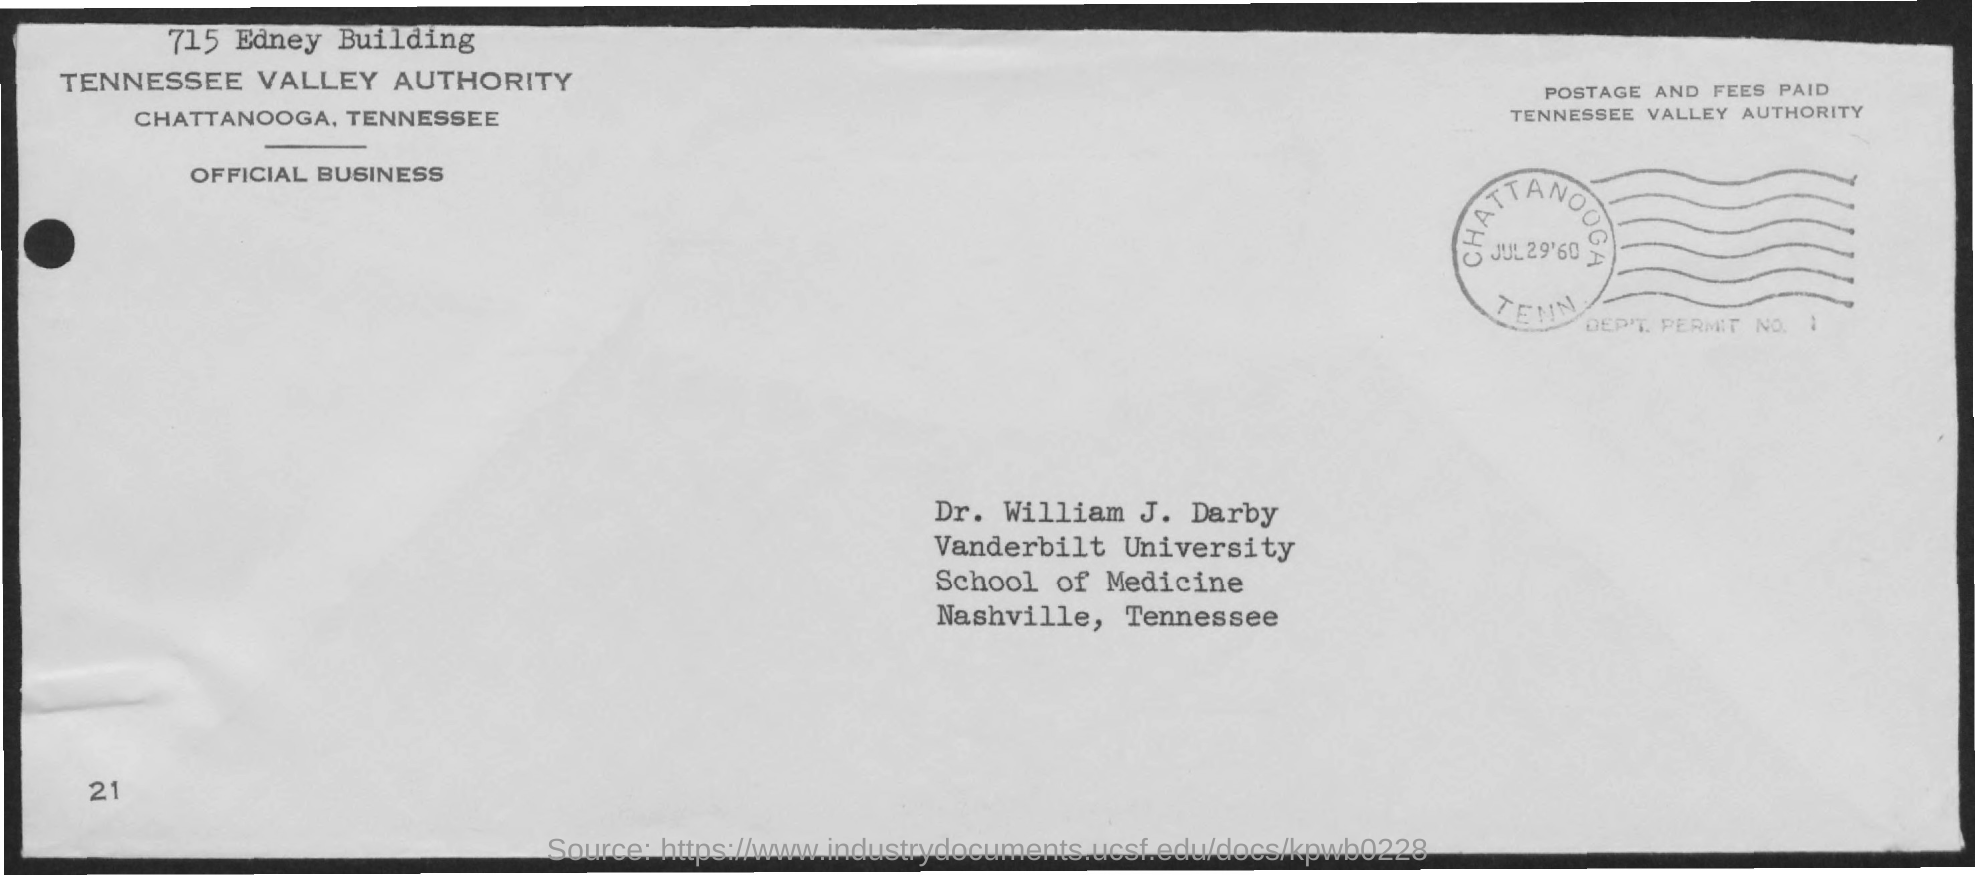Indicate a few pertinent items in this graphic. The person named in the address is Dr. William J. Darby. Dr. William J. Darby works at Vanderbilt University. 